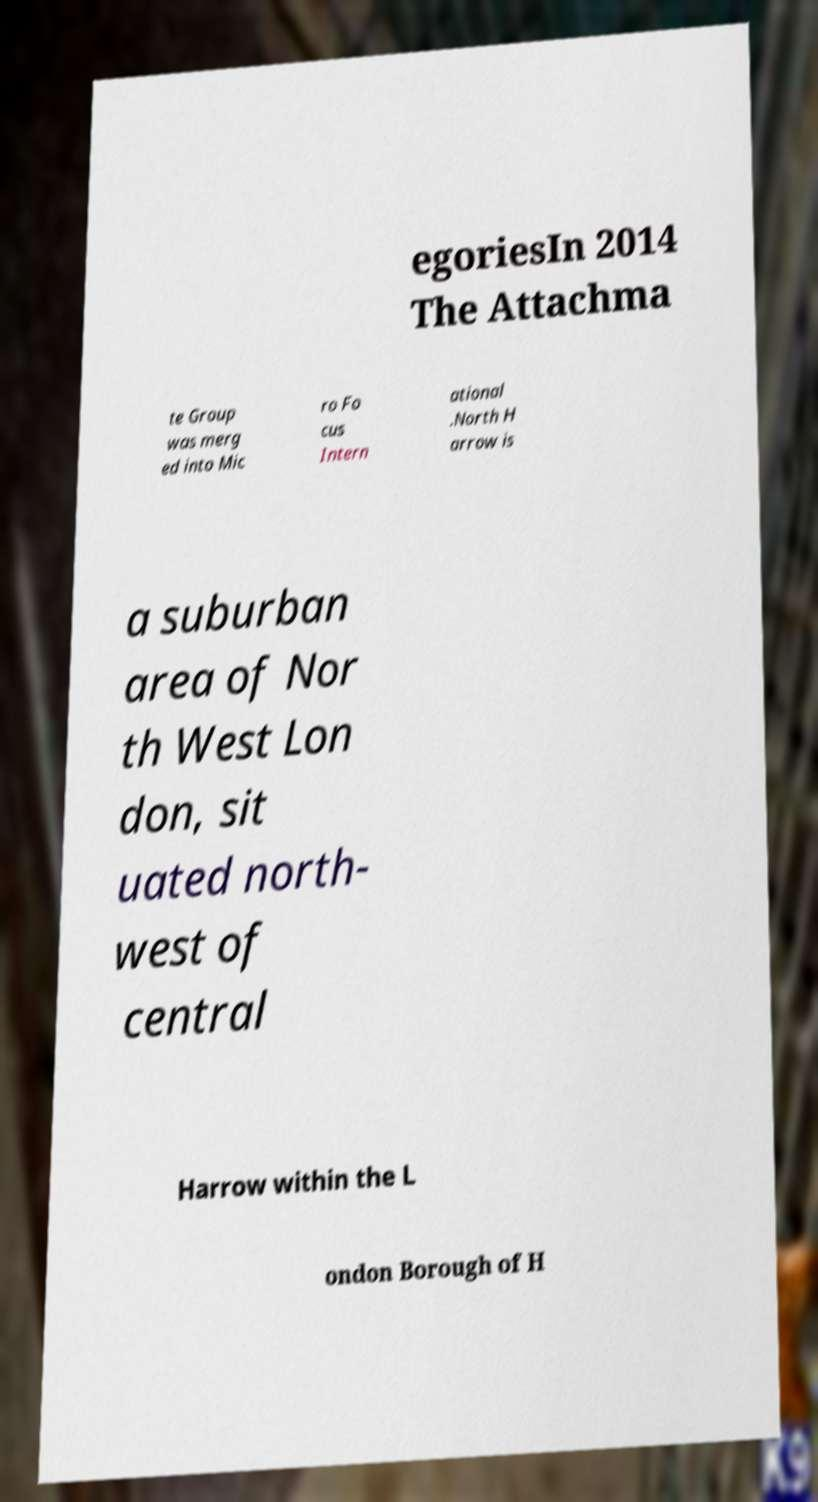There's text embedded in this image that I need extracted. Can you transcribe it verbatim? egoriesIn 2014 The Attachma te Group was merg ed into Mic ro Fo cus Intern ational .North H arrow is a suburban area of Nor th West Lon don, sit uated north- west of central Harrow within the L ondon Borough of H 